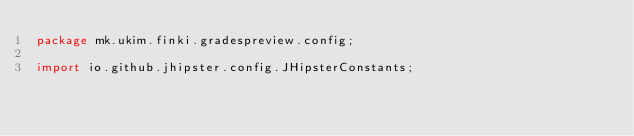<code> <loc_0><loc_0><loc_500><loc_500><_Java_>package mk.ukim.finki.gradespreview.config;

import io.github.jhipster.config.JHipsterConstants;</code> 